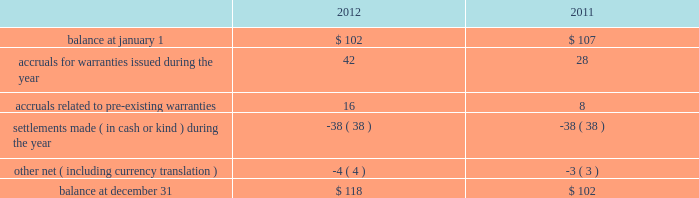Masco corporation notes to consolidated financial statements ( continued ) t .
Other commitments and contingencies litigation .
We are subject to claims , charges , litigation and other proceedings in the ordinary course of our business , including those arising from or related to contractual matters , intellectual property , personal injury , environmental matters , product liability , construction defect , insurance coverage , personnel and employment disputes and other matters , including class actions .
We believe we have adequate defenses in these matters and that the outcome of these matters is not likely to have a material adverse effect on us .
However , there is no assurance that we will prevail in these matters , and we could in the future incur judgments , enter into settlements of claims or revise our expectations regarding the outcome of these matters , which could materially impact our results of operations .
In july 2012 , the company reached a settlement agreement related to the columbus drywall litigation .
The company and its insulation installation companies named in the suit agreed to pay $ 75 million in return for dismissal with prejudice and full release of all claims .
The company and its insulation installation companies continue to deny that the challenged conduct was unlawful and admit no wrongdoing as part of the settlement .
A settlement was reached to eliminate the considerable expense and uncertainty of this lawsuit .
The company recorded the settlement expense in the second quarter of 2012 and the amount was paid in the fourth quarter of 2012 .
Warranty .
At the time of sale , the company accrues a warranty liability for the estimated cost to provide products , parts or services to repair or replace products in satisfaction of warranty obligations .
During the third quarter of 2012 , a business in the other specialty products segment recorded a $ 12 million increase in expected future warranty claims resulting from the completion of an analysis prepared by the company based upon its periodic assessment of recent business unit specific operating trends including , among others , home ownership demographics , sales volumes , manufacturing quality , an analysis of recent warranty claim activity and an estimate of current costs to service anticipated claims .
Changes in the company 2019s warranty liability were as follows , in millions: .
Investments .
With respect to the company 2019s investments in private equity funds , the company had , at december 31 , 2012 , commitments to contribute up to $ 19 million of additional capital to such funds representing the company 2019s aggregate capital commitment to such funds less capital contributions made to date .
The company is contractually obligated to make additional capital contributions to certain of its private equity funds upon receipt of a capital call from the private equity fund .
The company has no control over when or if the capital calls will occur .
Capital calls are funded in cash and generally result in an increase in the carrying value of the company 2019s investment in the private equity fund when paid. .
What was the percent of the change in the company 2019s warranty liability from 2011 to 2012? 
Rationale: the company 2019s warranty liability increased by 15.7% from 2011 to 2012
Computations: ((118 - 102) / 102)
Answer: 0.15686. 